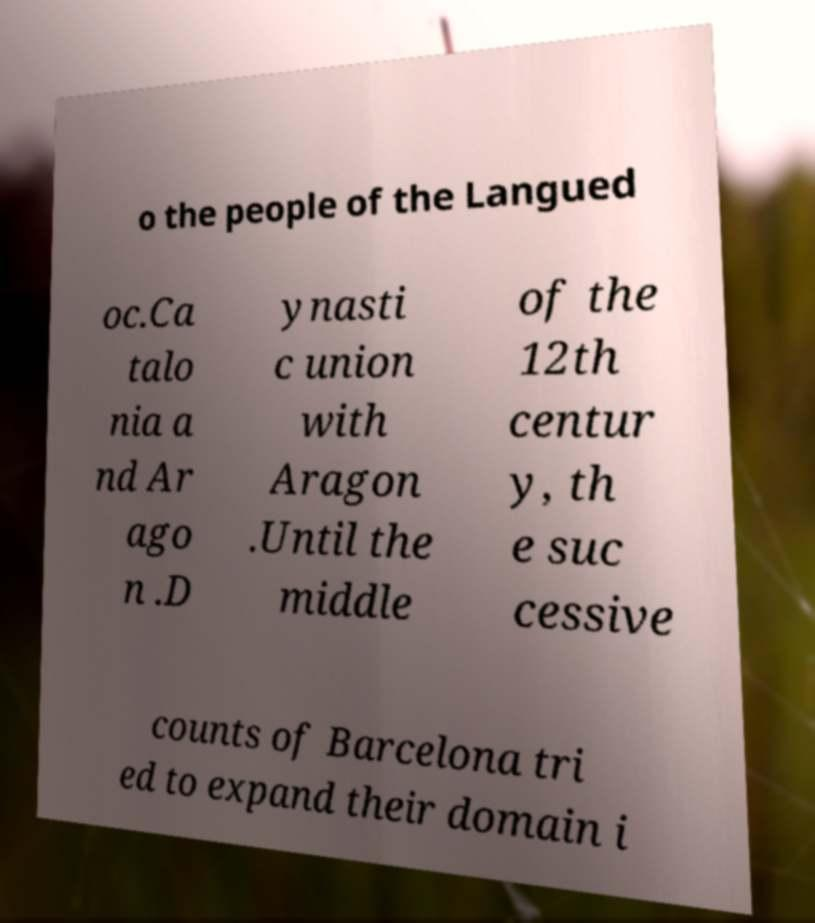Please read and relay the text visible in this image. What does it say? o the people of the Langued oc.Ca talo nia a nd Ar ago n .D ynasti c union with Aragon .Until the middle of the 12th centur y, th e suc cessive counts of Barcelona tri ed to expand their domain i 